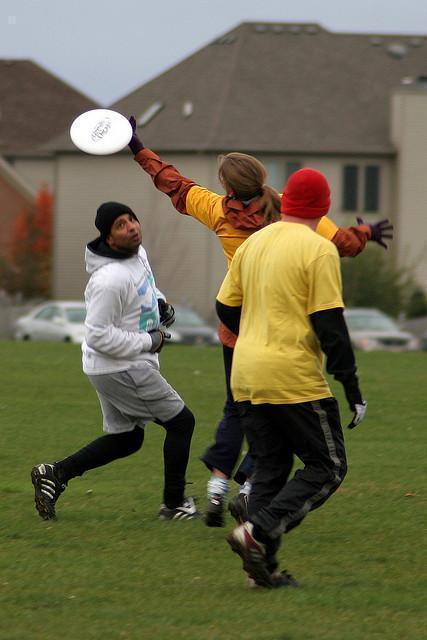What sport is being played?
Answer the question by selecting the correct answer among the 4 following choices and explain your choice with a short sentence. The answer should be formatted with the following format: `Answer: choice
Rationale: rationale.`
Options: Hockey, soccer, ultimate frisbee, football. Answer: ultimate frisbee.
Rationale: The frisbee is being used. 